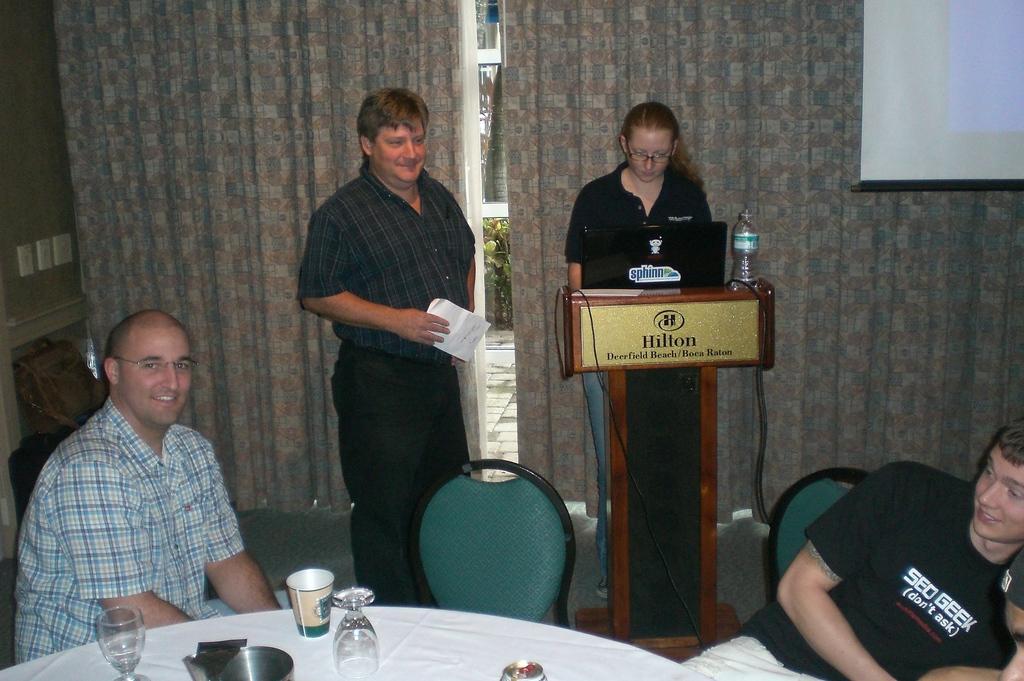Could you give a brief overview of what you see in this image? In this picture there is a table at the bottom side of the image, on which there are glasses and there are people those who are sitting around the table and there is a man who is standing in the center of the image, by holding a paper in his hand and there is a lady who is standing on the right side of the image in front of a desk and there is a laptop on the desk and there are curtains in the background area of the image, there is a chair at the bottom side of the image. 